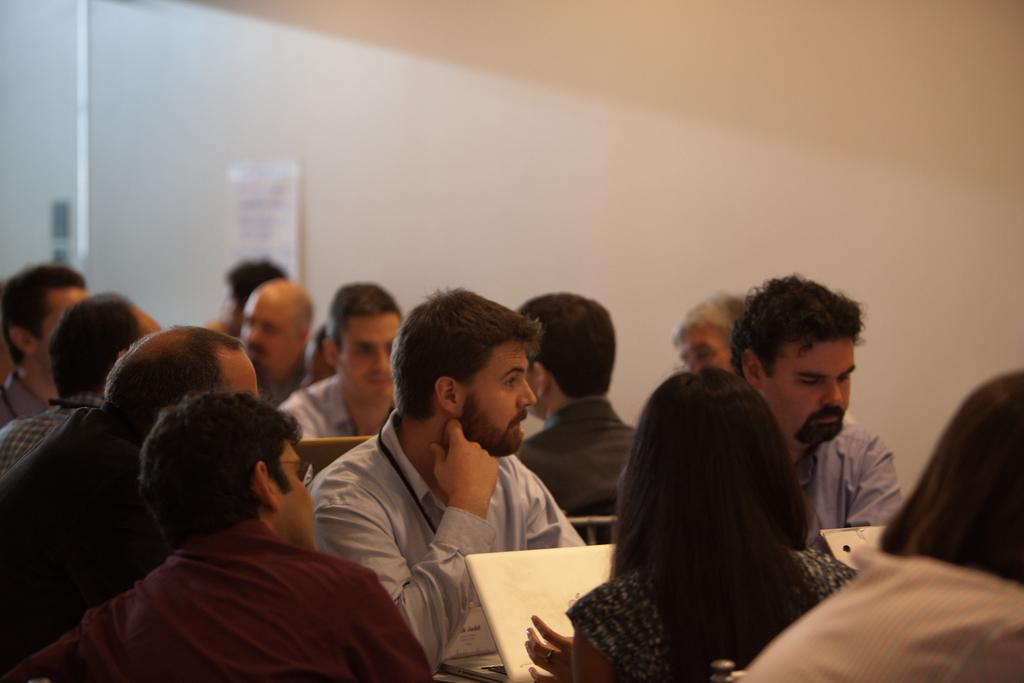What are the people in the image doing? The people in the image are sitting on chairs. Can you describe the gender of the people in the image? There are both men and women in the image. What can be seen in the background of the image? There is a wall in the background of the image. What type of account does the kitty have in the image? There is no kitty or account present in the image. What is the kitty painting on the canvas in the image? There is no kitty or canvas present in the image. 